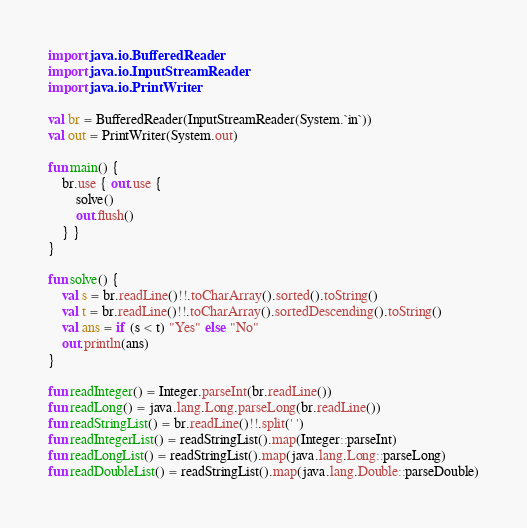Convert code to text. <code><loc_0><loc_0><loc_500><loc_500><_Kotlin_>import java.io.BufferedReader
import java.io.InputStreamReader
import java.io.PrintWriter

val br = BufferedReader(InputStreamReader(System.`in`))
val out = PrintWriter(System.out)

fun main() {
    br.use { out.use {
        solve()
        out.flush()
    } }
}

fun solve() {
    val s = br.readLine()!!.toCharArray().sorted().toString()
    val t = br.readLine()!!.toCharArray().sortedDescending().toString()
    val ans = if (s < t) "Yes" else "No"
    out.println(ans)
}

fun readInteger() = Integer.parseInt(br.readLine())
fun readLong() = java.lang.Long.parseLong(br.readLine())
fun readStringList() = br.readLine()!!.split(' ')
fun readIntegerList() = readStringList().map(Integer::parseInt)
fun readLongList() = readStringList().map(java.lang.Long::parseLong)
fun readDoubleList() = readStringList().map(java.lang.Double::parseDouble)
</code> 